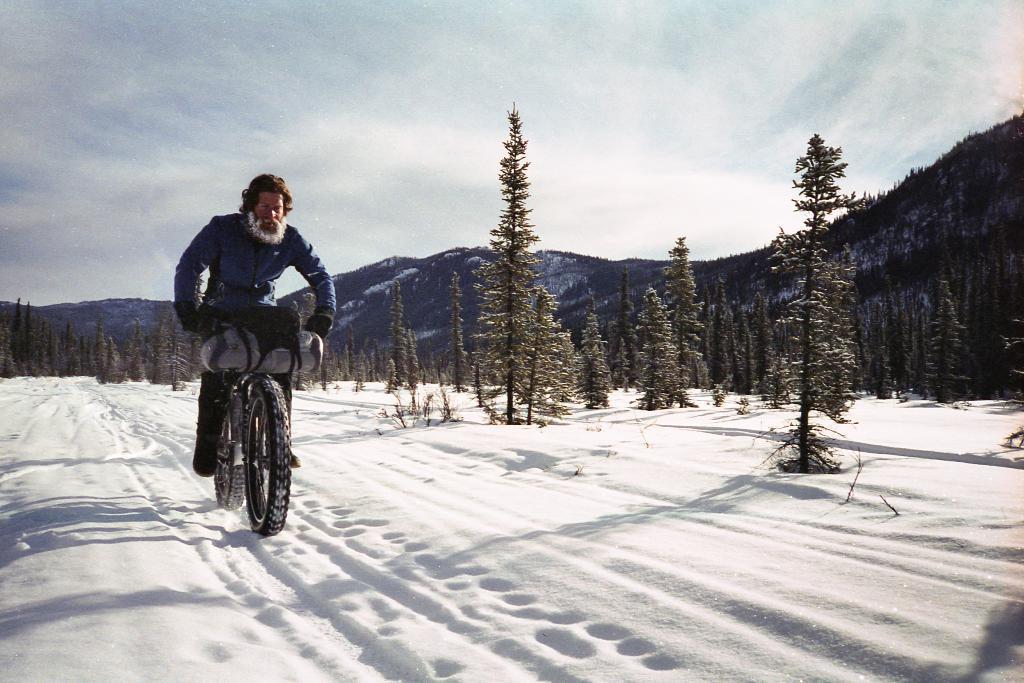Please provide a concise description of this image. At the bottom of the image there is snow. In the middle of the image a man is riding a bicycle. Behind him there are some trees and hills. At the top of the image there are some clouds and sky. 